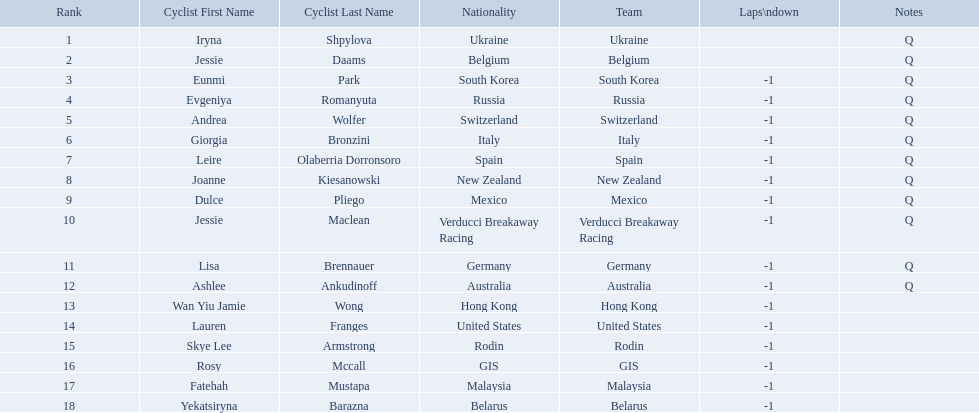Who are all the cyclists? Iryna Shpylova, Jessie Daams, Eunmi Park, Evgeniya Romanyuta, Andrea Wolfer, Giorgia Bronzini, Leire Olaberria Dorronsoro, Joanne Kiesanowski, Dulce Pliego, Jessie Maclean, Lisa Brennauer, Ashlee Ankudinoff, Wan Yiu Jamie Wong, Lauren Franges, Skye Lee Armstrong, Rosy Mccall, Fatehah Mustapa, Yekatsiryna Barazna. What were their ranks? 1, 2, 3, 4, 5, 6, 7, 8, 9, 10, 11, 12, 13, 14, 15, 16, 17, 18. Who was ranked highest? Iryna Shpylova. 